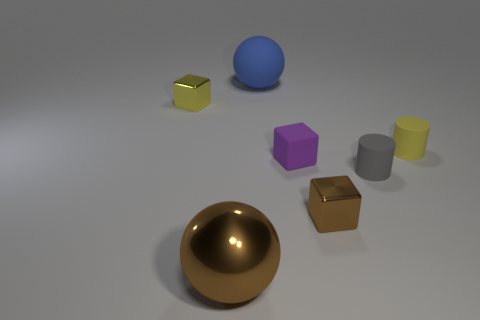What is the shape of the other shiny object that is the same color as the big metal object? The shape of the other object that shares the same shiny gold color as the large sphere is a cube. 